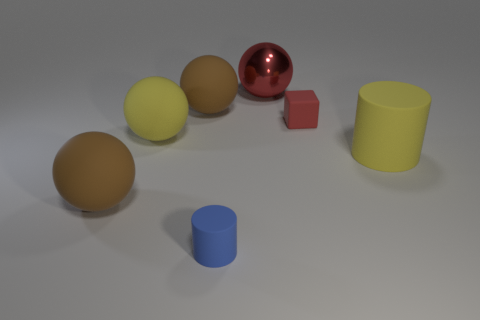What size is the other yellow object that is the same shape as the shiny thing?
Your answer should be compact. Large. What is the material of the big cylinder?
Give a very brief answer. Rubber. There is a large sphere that is on the left side of the yellow thing that is on the left side of the cylinder to the right of the tiny blue rubber thing; what is it made of?
Provide a short and direct response. Rubber. Is there anything else that has the same shape as the tiny red matte thing?
Your answer should be compact. No. What is the color of the other large thing that is the same shape as the blue object?
Your answer should be compact. Yellow. There is a matte ball that is behind the yellow ball; is its color the same as the ball that is in front of the big yellow rubber cylinder?
Your response must be concise. Yes. Are there more large brown spheres behind the large yellow cylinder than tiny green cylinders?
Ensure brevity in your answer.  Yes. How many other objects are the same size as the red metallic thing?
Ensure brevity in your answer.  4. How many rubber things are both to the right of the large yellow sphere and on the left side of the yellow matte ball?
Your answer should be very brief. 0. Is the big object that is on the left side of the big yellow rubber sphere made of the same material as the tiny cube?
Your answer should be very brief. Yes. 